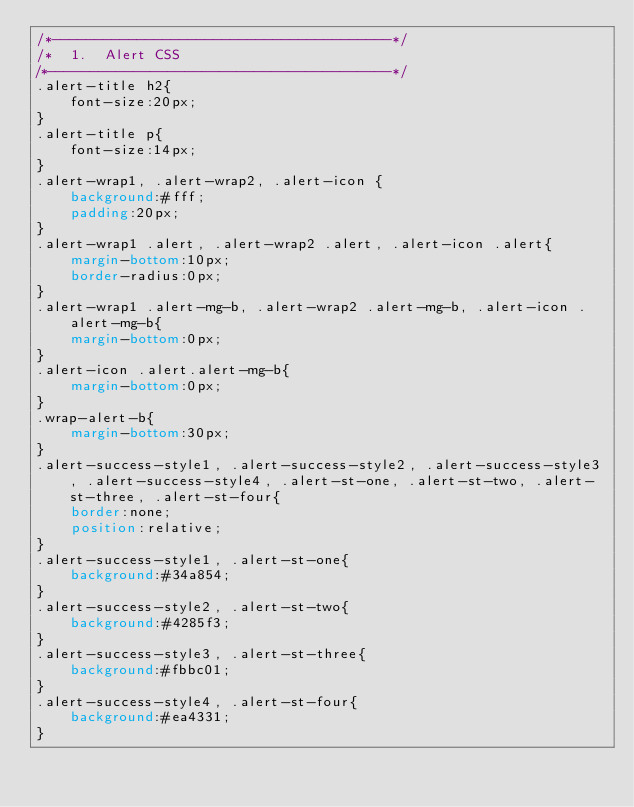<code> <loc_0><loc_0><loc_500><loc_500><_CSS_>/*----------------------------------------*/
/*  1.  Alert CSS
/*----------------------------------------*/
.alert-title h2{
	font-size:20px;
}
.alert-title p{
	font-size:14px;
}
.alert-wrap1, .alert-wrap2, .alert-icon {
	background:#fff;
	padding:20px;
}
.alert-wrap1 .alert, .alert-wrap2 .alert, .alert-icon .alert{
	margin-bottom:10px;
	border-radius:0px;
}
.alert-wrap1 .alert-mg-b, .alert-wrap2 .alert-mg-b, .alert-icon .alert-mg-b{
	margin-bottom:0px;
}
.alert-icon .alert.alert-mg-b{
	margin-bottom:0px;
}
.wrap-alert-b{
	margin-bottom:30px;
}
.alert-success-style1, .alert-success-style2, .alert-success-style3, .alert-success-style4, .alert-st-one, .alert-st-two, .alert-st-three, .alert-st-four{
	border:none;
	position:relative;
}
.alert-success-style1, .alert-st-one{
	background:#34a854;
}
.alert-success-style2, .alert-st-two{
	background:#4285f3;
}
.alert-success-style3, .alert-st-three{
	background:#fbbc01;
}
.alert-success-style4, .alert-st-four{
	background:#ea4331;
}</code> 